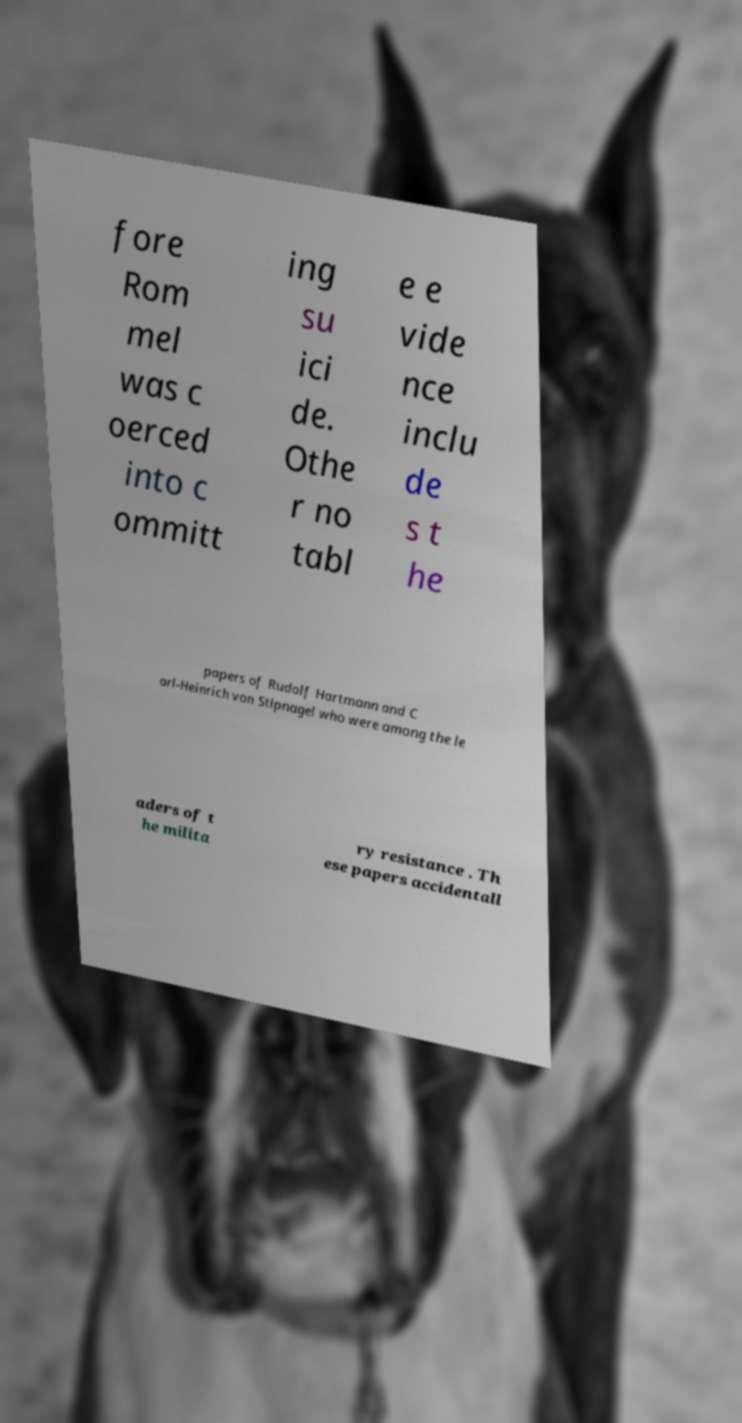Please identify and transcribe the text found in this image. fore Rom mel was c oerced into c ommitt ing su ici de. Othe r no tabl e e vide nce inclu de s t he papers of Rudolf Hartmann and C arl-Heinrich von Stlpnagel who were among the le aders of t he milita ry resistance . Th ese papers accidentall 